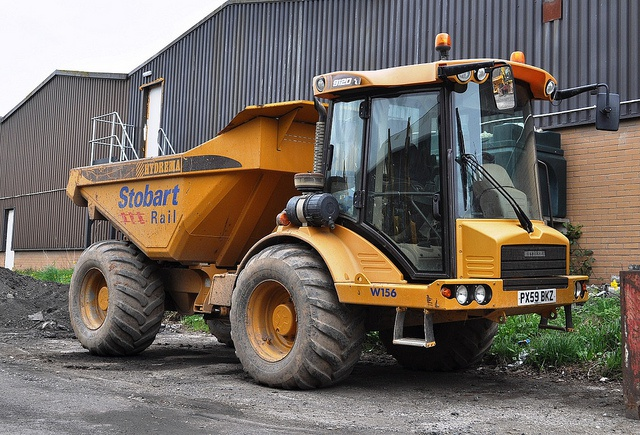Describe the objects in this image and their specific colors. I can see a truck in white, black, gray, maroon, and darkgray tones in this image. 